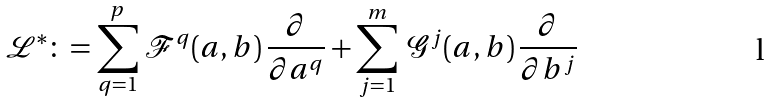<formula> <loc_0><loc_0><loc_500><loc_500>\mathcal { L } ^ { * } \colon = \sum _ { q = 1 } ^ { p } \, \mathcal { F } ^ { q } ( a , b ) \, \frac { \partial } { \partial a ^ { q } } + \sum _ { j = 1 } ^ { m } \, \mathcal { G } ^ { j } ( a , b ) \, \frac { \partial } { \partial b ^ { j } }</formula> 